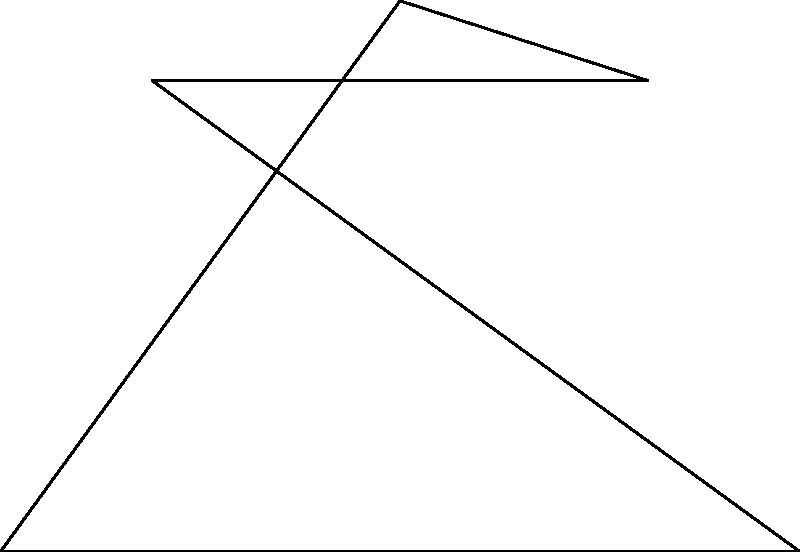In designing a magical portal for your stage, you've created a perfect pentagram inscribed in a circle. If the ratio of the length of a side of the pentagram to the radius of the circle is $\frac{2\sqrt{5-2\sqrt{5}}}{5}$, and the angle $\angle AOB$ is $72°$, find the ratio of $x$ to $y$ in the diagram, where $x$ is the distance from the center to a vertex and $y$ is the distance from the center to the midpoint of a side. Let's approach this step-by-step:

1) In a regular pentagram, the ratio of a side to the radius of the circumscribed circle is given as $\frac{2\sqrt{5-2\sqrt{5}}}{5}$. Let's call the radius $r$ and the side length $s$.

   $\frac{s}{r} = \frac{2\sqrt{5-2\sqrt{5}}}{5}$

2) In a regular pentagon, the central angle $\angle AOB$ is $72°$ or $\frac{2\pi}{5}$ radians.

3) The distance $x$ from the center to a vertex is simply the radius $r$.

4) To find $y$, we need to use the cosine function:

   $y = r \cos(36°)$, because $36° = \frac{72°}{2}$

5) We know that $\cos(36°) = \frac{\sqrt{5}+1}{4}$

6) Therefore, $y = r \cdot \frac{\sqrt{5}+1}{4}$

7) The ratio $\frac{x}{y}$ is:

   $\frac{x}{y} = \frac{r}{r \cdot \frac{\sqrt{5}+1}{4}} = \frac{4}{\sqrt{5}+1}$

8) We can rationalize this:

   $\frac{4}{\sqrt{5}+1} \cdot \frac{\sqrt{5}-1}{\sqrt{5}-1} = \frac{4(\sqrt{5}-1)}{5-1} = \sqrt{5}-1$

Thus, the ratio of $x$ to $y$ is $\sqrt{5}-1 : 1$ or $\sqrt{5}-1$.
Answer: $\sqrt{5}-1$ 